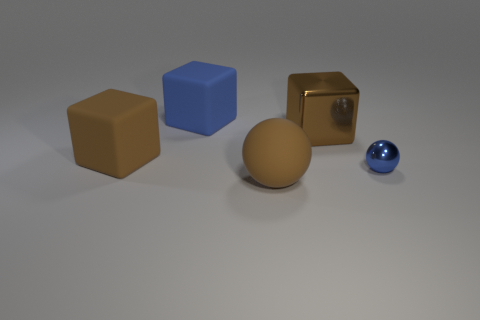Subtract all brown cubes. How many were subtracted if there are1brown cubes left? 1 Subtract all brown metallic cubes. How many cubes are left? 2 Subtract all green cylinders. How many blue spheres are left? 1 Add 4 yellow metallic things. How many objects exist? 9 Subtract all brown balls. How many balls are left? 1 Subtract 1 balls. How many balls are left? 1 Subtract all blocks. How many objects are left? 2 Subtract all big brown spheres. Subtract all large metal cubes. How many objects are left? 3 Add 2 brown balls. How many brown balls are left? 3 Add 5 rubber objects. How many rubber objects exist? 8 